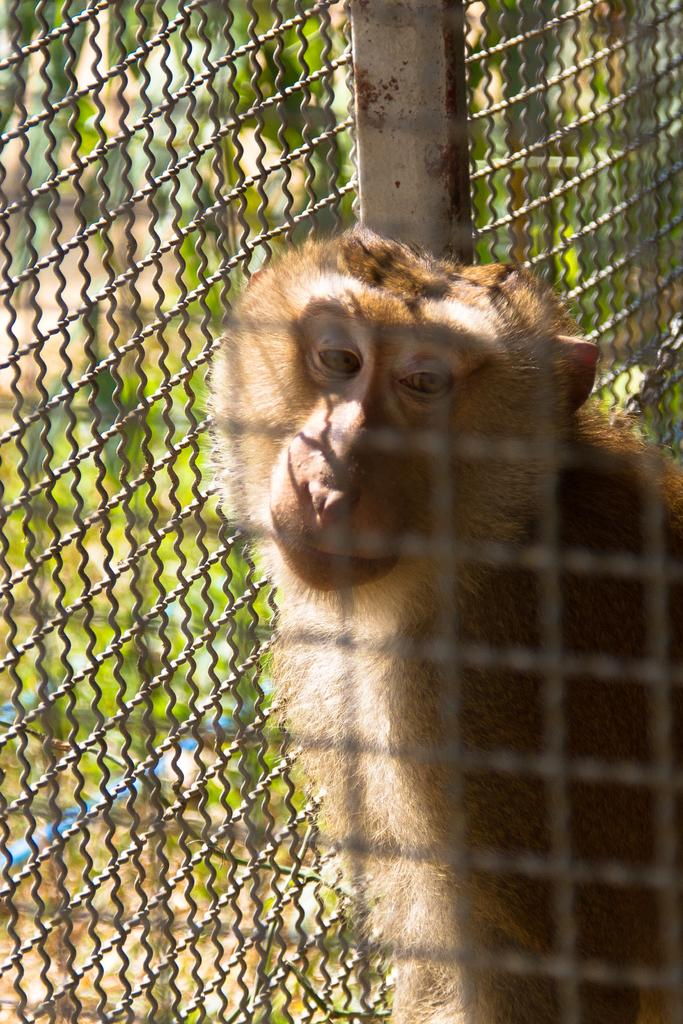What type of animal is in the image? There is a monkey in the image. What is the monkey contained within in the image? There is a cage in the image. What type of frame surrounds the monkey in the image? There is no frame surrounding the monkey in the image; it is contained within a cage. What color are the monkey's eyes in the image? The color of the monkey's eyes cannot be determined from the image. 